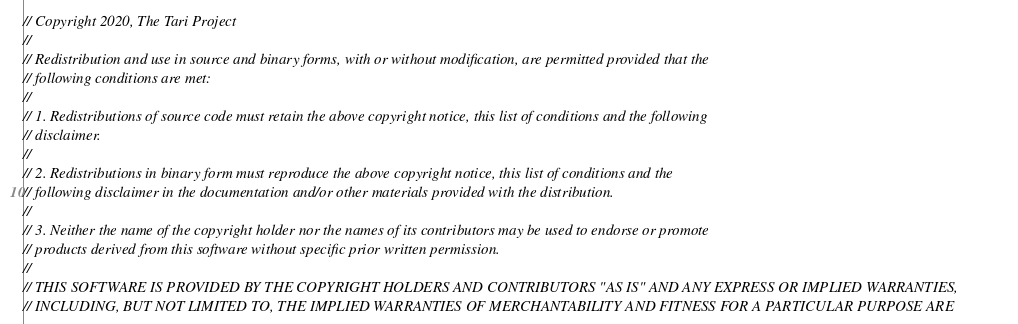Convert code to text. <code><loc_0><loc_0><loc_500><loc_500><_Rust_>// Copyright 2020, The Tari Project
//
// Redistribution and use in source and binary forms, with or without modification, are permitted provided that the
// following conditions are met:
//
// 1. Redistributions of source code must retain the above copyright notice, this list of conditions and the following
// disclaimer.
//
// 2. Redistributions in binary form must reproduce the above copyright notice, this list of conditions and the
// following disclaimer in the documentation and/or other materials provided with the distribution.
//
// 3. Neither the name of the copyright holder nor the names of its contributors may be used to endorse or promote
// products derived from this software without specific prior written permission.
//
// THIS SOFTWARE IS PROVIDED BY THE COPYRIGHT HOLDERS AND CONTRIBUTORS "AS IS" AND ANY EXPRESS OR IMPLIED WARRANTIES,
// INCLUDING, BUT NOT LIMITED TO, THE IMPLIED WARRANTIES OF MERCHANTABILITY AND FITNESS FOR A PARTICULAR PURPOSE ARE</code> 